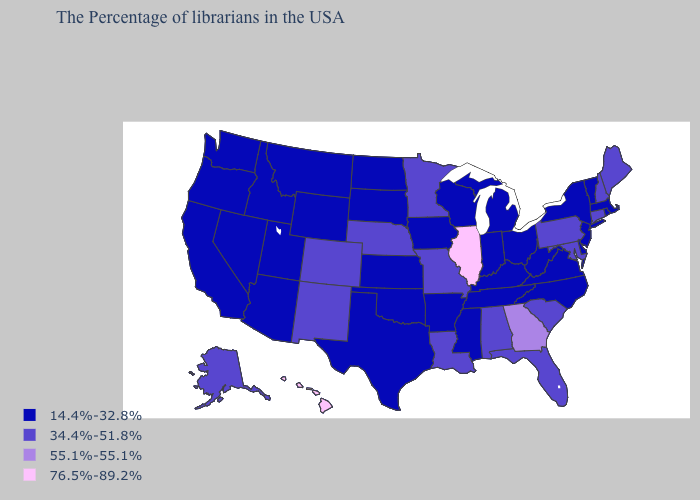Name the states that have a value in the range 76.5%-89.2%?
Concise answer only. Illinois, Hawaii. Does Hawaii have the same value as Illinois?
Be succinct. Yes. What is the highest value in the West ?
Give a very brief answer. 76.5%-89.2%. What is the value of Idaho?
Be succinct. 14.4%-32.8%. Does the first symbol in the legend represent the smallest category?
Short answer required. Yes. Does California have a lower value than Wyoming?
Give a very brief answer. No. What is the value of Georgia?
Answer briefly. 55.1%-55.1%. Does Utah have the same value as Oregon?
Keep it brief. Yes. Name the states that have a value in the range 76.5%-89.2%?
Short answer required. Illinois, Hawaii. Does Connecticut have the lowest value in the USA?
Quick response, please. No. Name the states that have a value in the range 76.5%-89.2%?
Short answer required. Illinois, Hawaii. Which states have the lowest value in the USA?
Quick response, please. Massachusetts, Rhode Island, Vermont, New York, New Jersey, Delaware, Virginia, North Carolina, West Virginia, Ohio, Michigan, Kentucky, Indiana, Tennessee, Wisconsin, Mississippi, Arkansas, Iowa, Kansas, Oklahoma, Texas, South Dakota, North Dakota, Wyoming, Utah, Montana, Arizona, Idaho, Nevada, California, Washington, Oregon. Name the states that have a value in the range 55.1%-55.1%?
Give a very brief answer. Georgia. Name the states that have a value in the range 14.4%-32.8%?
Give a very brief answer. Massachusetts, Rhode Island, Vermont, New York, New Jersey, Delaware, Virginia, North Carolina, West Virginia, Ohio, Michigan, Kentucky, Indiana, Tennessee, Wisconsin, Mississippi, Arkansas, Iowa, Kansas, Oklahoma, Texas, South Dakota, North Dakota, Wyoming, Utah, Montana, Arizona, Idaho, Nevada, California, Washington, Oregon. Does New Hampshire have the lowest value in the Northeast?
Concise answer only. No. 